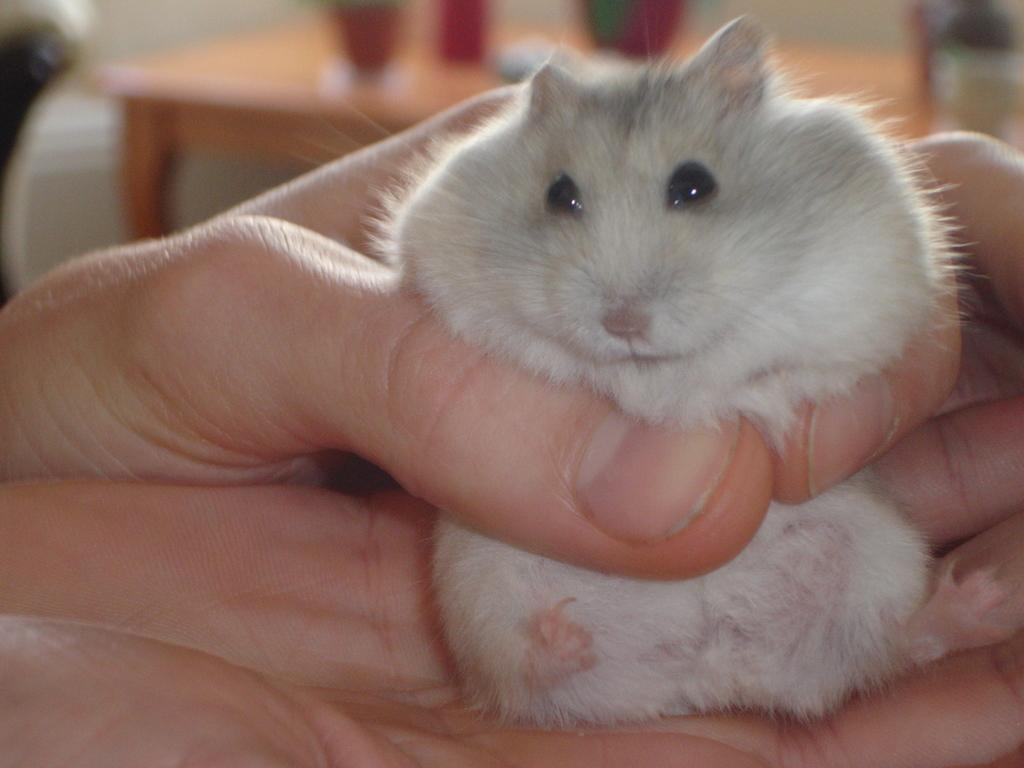What is being held by the human hands in the image? There is an animal being held by human hands in the image. What can be seen in the background of the image? There is a table and glasses in the background of the image. How does the animal contribute to the growth of the plants in the image? There are no plants present in the image, so the animal's contribution to plant growth cannot be determined. 